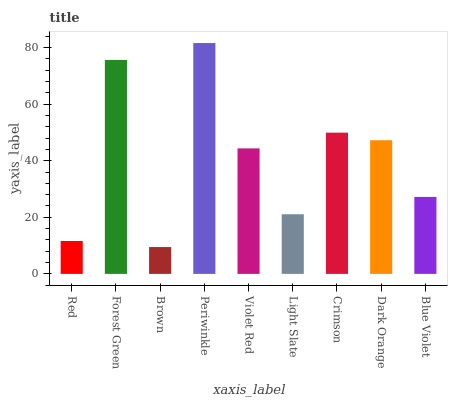Is Brown the minimum?
Answer yes or no. Yes. Is Periwinkle the maximum?
Answer yes or no. Yes. Is Forest Green the minimum?
Answer yes or no. No. Is Forest Green the maximum?
Answer yes or no. No. Is Forest Green greater than Red?
Answer yes or no. Yes. Is Red less than Forest Green?
Answer yes or no. Yes. Is Red greater than Forest Green?
Answer yes or no. No. Is Forest Green less than Red?
Answer yes or no. No. Is Violet Red the high median?
Answer yes or no. Yes. Is Violet Red the low median?
Answer yes or no. Yes. Is Crimson the high median?
Answer yes or no. No. Is Dark Orange the low median?
Answer yes or no. No. 